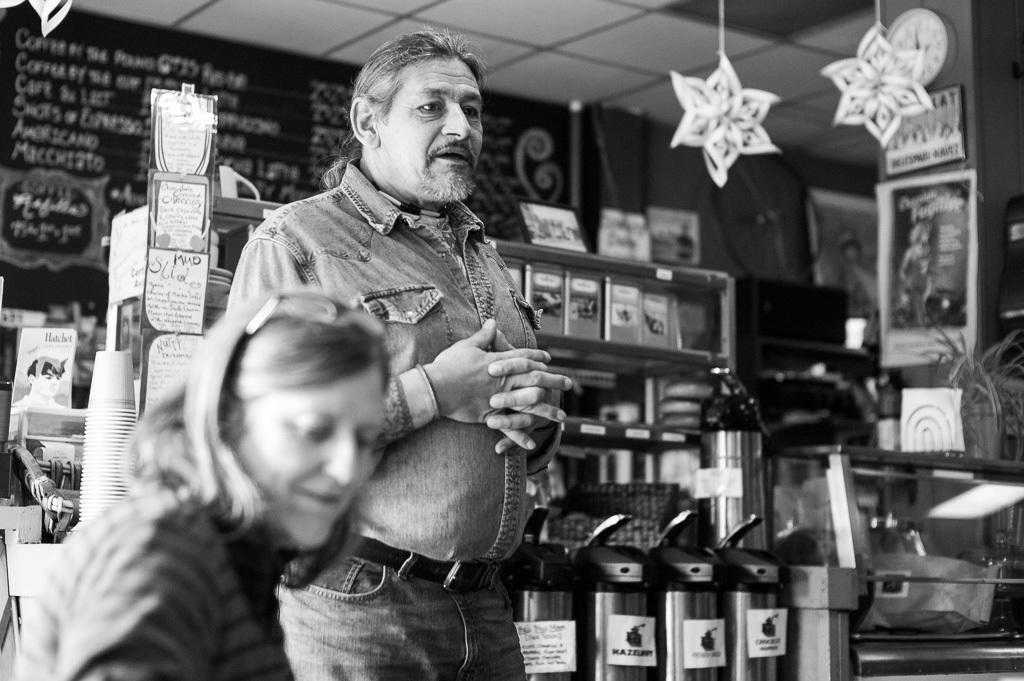Can you describe this image briefly? This is a black and white picture, in this image we can see two persons, behind them, we can see a cupboard with some books and other objects on it, there are some posters, cups, potted plants and some other objects, in the background we can see a board with some text and also we can see a photo frame on the wall. 